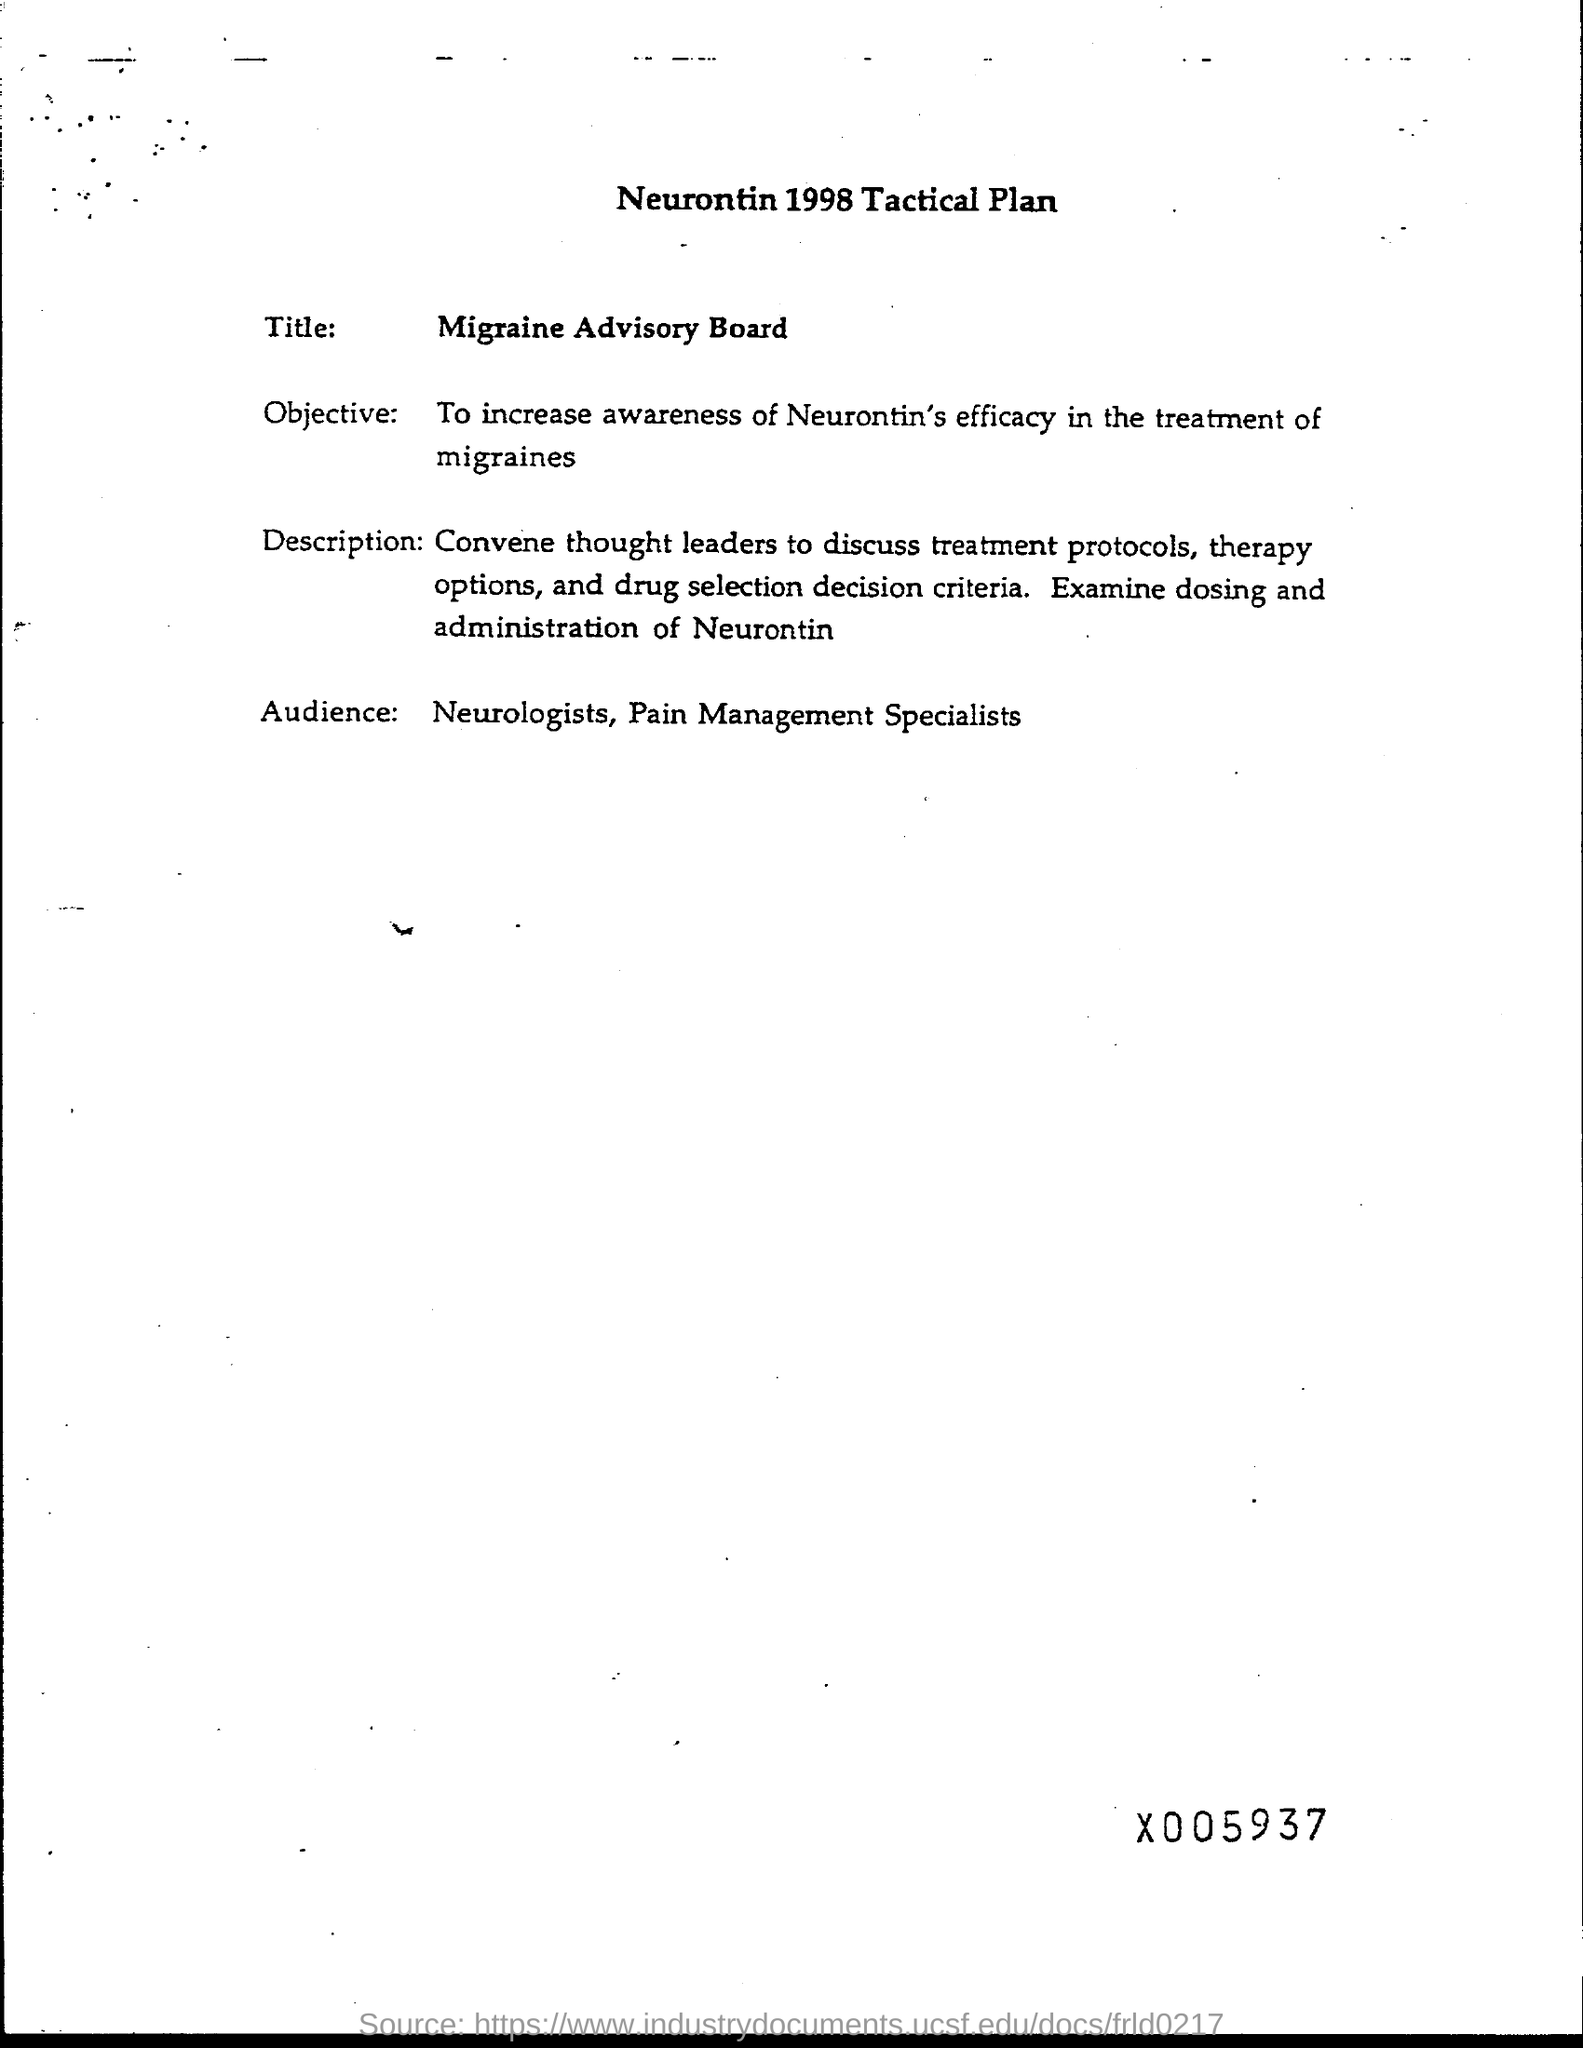Specify some key components in this picture. The efficacy of Neurontin in the treatment of migraines is being explored, and it is important to increase awareness about the potential benefits of this medication. The year mentioned in the heading of the document is 1998. The heading is 'What is the Neurontin 1998 Tactical Plan?' The intended audience for this content includes neurologists and pain management specialists. 